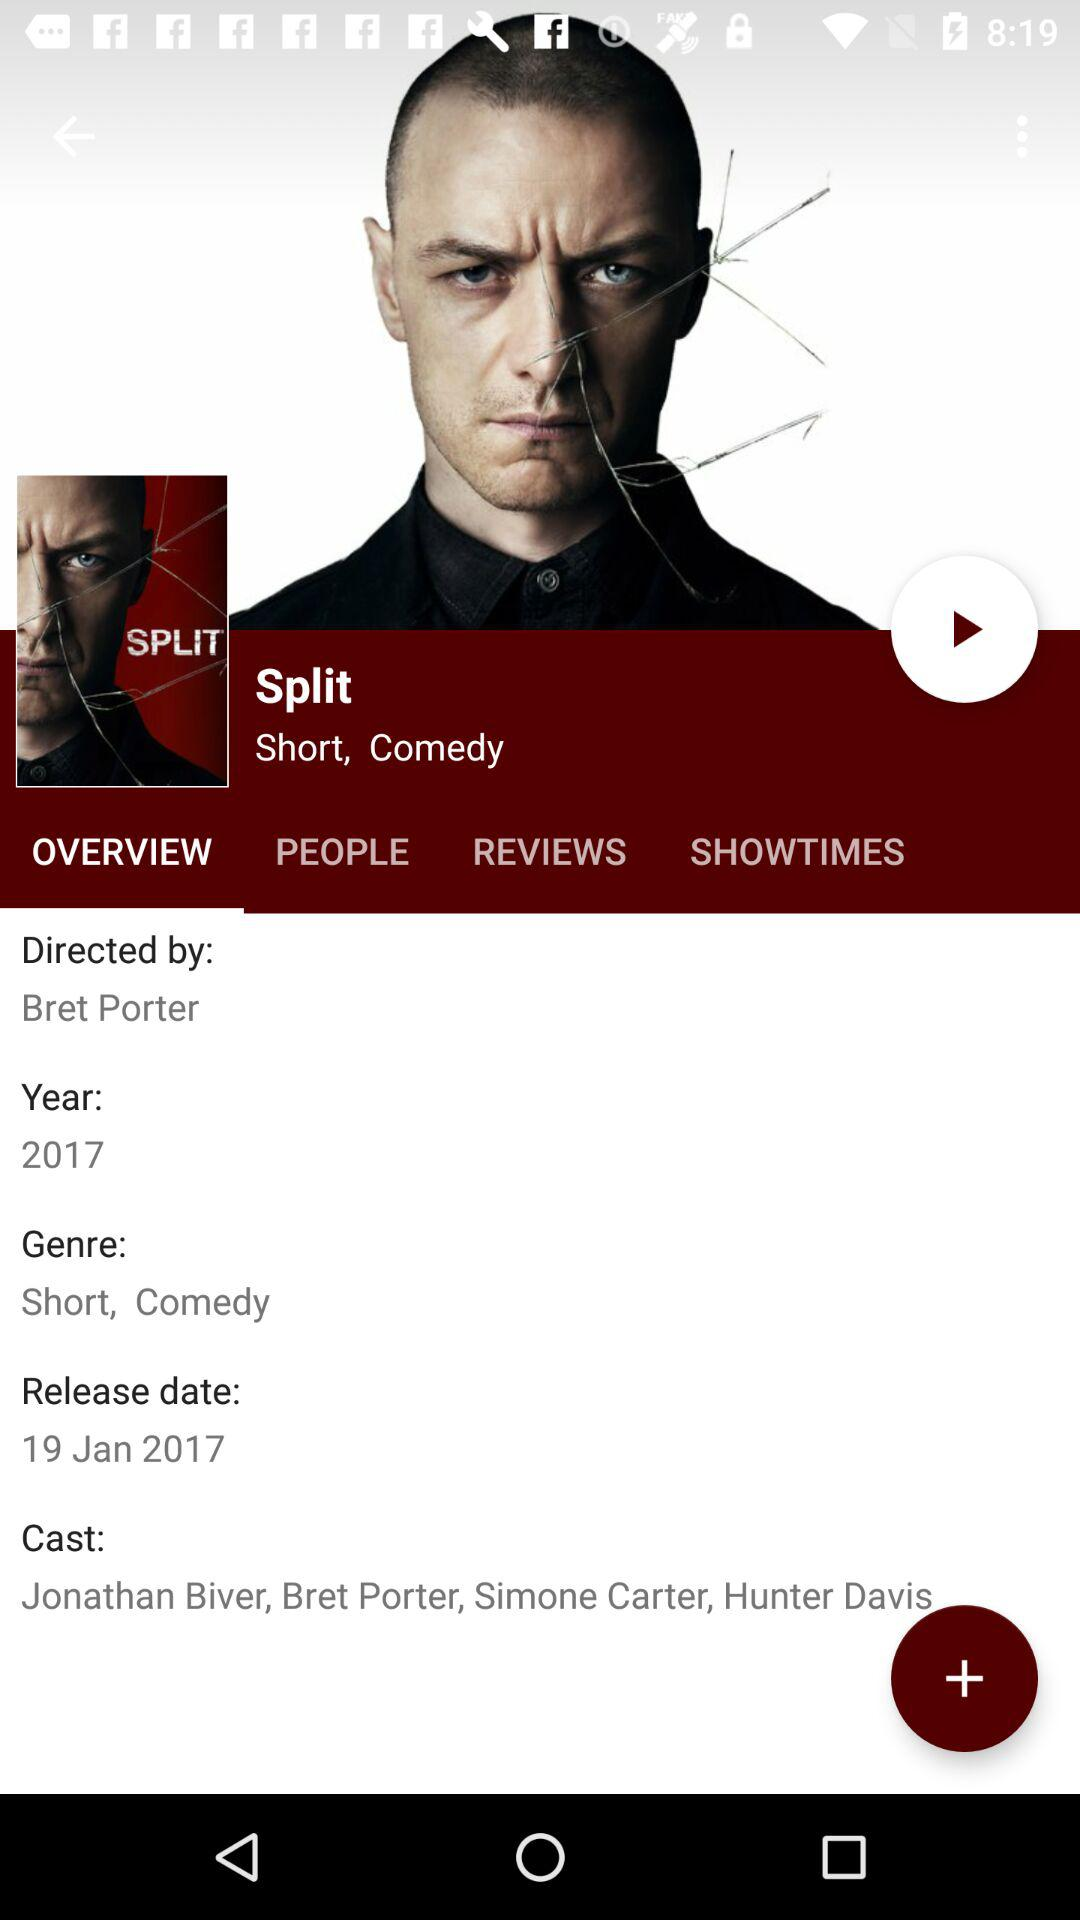What is the name of the movie? The name of the movie is "Split". 